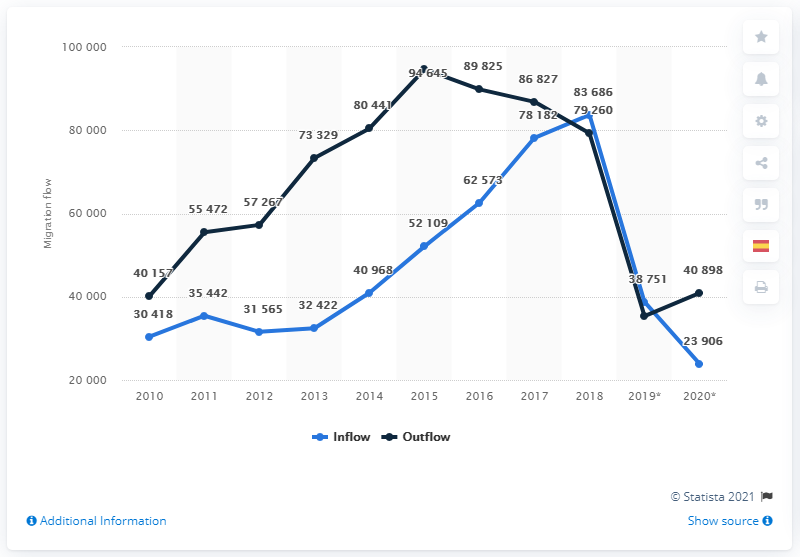What factors might have contributed to the sharp decline in Spaniards returning to Spain after 2016? The sharp decline seen after 2016 could be linked to various economic, social, or political changes within Spain or in those countries where Spaniards were previously residing. Some contributing factors might include improvements in the Spanish economy, which reduced the need to return, or changes in immigration policies in other countries. Could the economic crisis in Spain earlier have initiated a higher inflow of Spaniards returning? Absolutely, the economic crisis in Spain around 2008-2013 led to high unemployment rates, prompting Spaniards to seek opportunities abroad. As the Spanish economy gradually recovered, we initially saw a rise in the number of returns, reflective of improved economic stability, which likely contributed to the inflow peak until 2016. 